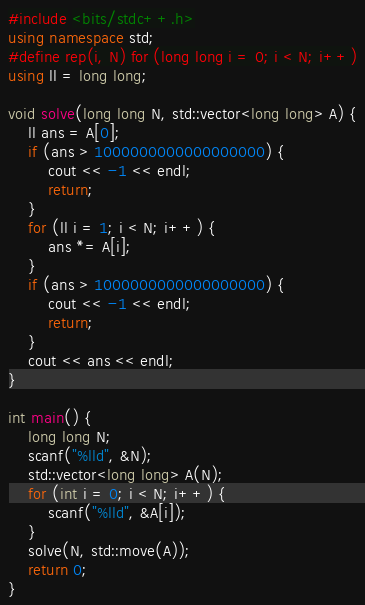Convert code to text. <code><loc_0><loc_0><loc_500><loc_500><_C++_>#include <bits/stdc++.h>
using namespace std;
#define rep(i, N) for (long long i = 0; i < N; i++)
using ll = long long;

void solve(long long N, std::vector<long long> A) {
    ll ans = A[0];
    if (ans > 1000000000000000000) {
        cout << -1 << endl;
        return;
    }
    for (ll i = 1; i < N; i++) {
        ans *= A[i];
    }
    if (ans > 1000000000000000000) {
        cout << -1 << endl;
        return;
    }
    cout << ans << endl;
}

int main() {
    long long N;
    scanf("%lld", &N);
    std::vector<long long> A(N);
    for (int i = 0; i < N; i++) {
        scanf("%lld", &A[i]);
    }
    solve(N, std::move(A));
    return 0;
}
</code> 